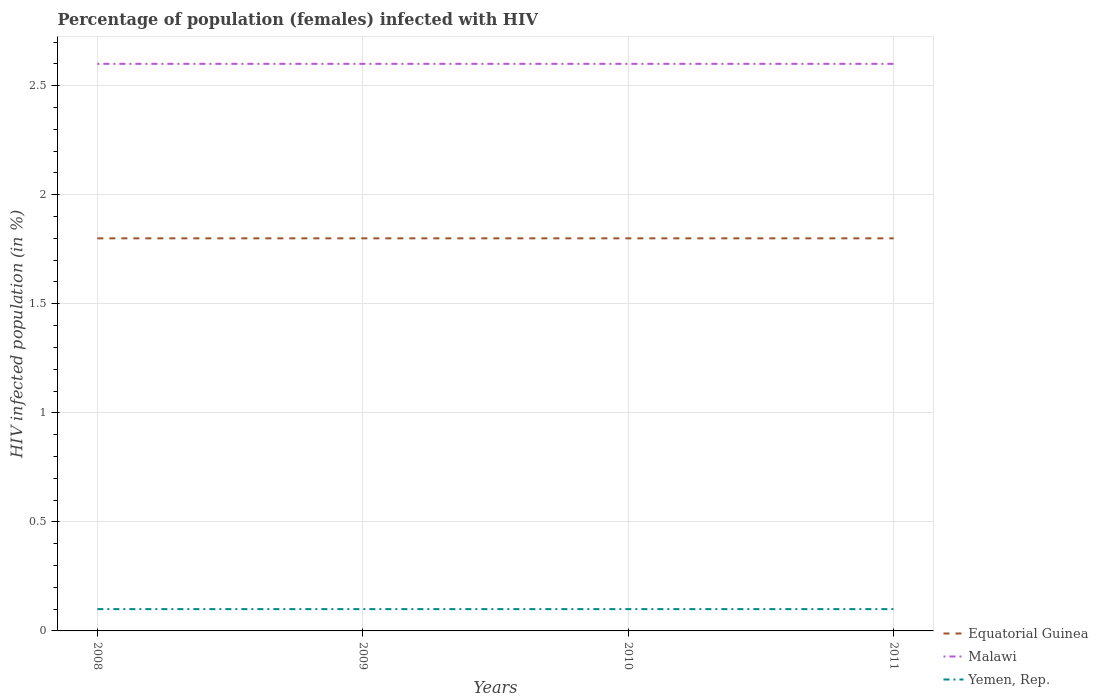Across all years, what is the maximum percentage of HIV infected female population in Equatorial Guinea?
Your answer should be compact. 1.8. In which year was the percentage of HIV infected female population in Yemen, Rep. maximum?
Provide a succinct answer. 2008. What is the difference between the highest and the second highest percentage of HIV infected female population in Malawi?
Ensure brevity in your answer.  0. Is the percentage of HIV infected female population in Equatorial Guinea strictly greater than the percentage of HIV infected female population in Yemen, Rep. over the years?
Give a very brief answer. No. How many lines are there?
Your answer should be very brief. 3. What is the difference between two consecutive major ticks on the Y-axis?
Offer a terse response. 0.5. Does the graph contain any zero values?
Give a very brief answer. No. Does the graph contain grids?
Ensure brevity in your answer.  Yes. How are the legend labels stacked?
Give a very brief answer. Vertical. What is the title of the graph?
Offer a terse response. Percentage of population (females) infected with HIV. Does "Cote d'Ivoire" appear as one of the legend labels in the graph?
Keep it short and to the point. No. What is the label or title of the Y-axis?
Ensure brevity in your answer.  HIV infected population (in %). What is the HIV infected population (in %) of Yemen, Rep. in 2008?
Provide a short and direct response. 0.1. What is the HIV infected population (in %) in Yemen, Rep. in 2009?
Make the answer very short. 0.1. What is the HIV infected population (in %) in Equatorial Guinea in 2010?
Make the answer very short. 1.8. What is the HIV infected population (in %) of Malawi in 2010?
Give a very brief answer. 2.6. Across all years, what is the maximum HIV infected population (in %) in Malawi?
Your answer should be compact. 2.6. Across all years, what is the minimum HIV infected population (in %) of Malawi?
Your answer should be very brief. 2.6. Across all years, what is the minimum HIV infected population (in %) of Yemen, Rep.?
Keep it short and to the point. 0.1. What is the total HIV infected population (in %) of Equatorial Guinea in the graph?
Your response must be concise. 7.2. What is the total HIV infected population (in %) of Malawi in the graph?
Your answer should be compact. 10.4. What is the difference between the HIV infected population (in %) of Equatorial Guinea in 2008 and that in 2009?
Give a very brief answer. 0. What is the difference between the HIV infected population (in %) in Malawi in 2008 and that in 2009?
Ensure brevity in your answer.  0. What is the difference between the HIV infected population (in %) in Yemen, Rep. in 2008 and that in 2009?
Give a very brief answer. 0. What is the difference between the HIV infected population (in %) in Malawi in 2008 and that in 2010?
Your response must be concise. 0. What is the difference between the HIV infected population (in %) in Yemen, Rep. in 2008 and that in 2010?
Offer a terse response. 0. What is the difference between the HIV infected population (in %) of Malawi in 2008 and that in 2011?
Offer a terse response. 0. What is the difference between the HIV infected population (in %) in Yemen, Rep. in 2008 and that in 2011?
Your answer should be compact. 0. What is the difference between the HIV infected population (in %) in Equatorial Guinea in 2009 and that in 2010?
Your response must be concise. 0. What is the difference between the HIV infected population (in %) in Malawi in 2009 and that in 2011?
Provide a short and direct response. 0. What is the difference between the HIV infected population (in %) in Yemen, Rep. in 2009 and that in 2011?
Give a very brief answer. 0. What is the difference between the HIV infected population (in %) of Equatorial Guinea in 2010 and that in 2011?
Provide a short and direct response. 0. What is the difference between the HIV infected population (in %) in Yemen, Rep. in 2010 and that in 2011?
Ensure brevity in your answer.  0. What is the difference between the HIV infected population (in %) of Equatorial Guinea in 2008 and the HIV infected population (in %) of Malawi in 2010?
Give a very brief answer. -0.8. What is the difference between the HIV infected population (in %) of Malawi in 2008 and the HIV infected population (in %) of Yemen, Rep. in 2010?
Provide a short and direct response. 2.5. What is the difference between the HIV infected population (in %) of Equatorial Guinea in 2008 and the HIV infected population (in %) of Yemen, Rep. in 2011?
Ensure brevity in your answer.  1.7. What is the difference between the HIV infected population (in %) of Malawi in 2008 and the HIV infected population (in %) of Yemen, Rep. in 2011?
Keep it short and to the point. 2.5. What is the difference between the HIV infected population (in %) of Equatorial Guinea in 2009 and the HIV infected population (in %) of Malawi in 2010?
Your answer should be compact. -0.8. What is the difference between the HIV infected population (in %) in Malawi in 2009 and the HIV infected population (in %) in Yemen, Rep. in 2010?
Keep it short and to the point. 2.5. What is the average HIV infected population (in %) in Malawi per year?
Your answer should be compact. 2.6. What is the average HIV infected population (in %) of Yemen, Rep. per year?
Your answer should be compact. 0.1. In the year 2008, what is the difference between the HIV infected population (in %) in Equatorial Guinea and HIV infected population (in %) in Malawi?
Your answer should be very brief. -0.8. In the year 2008, what is the difference between the HIV infected population (in %) of Equatorial Guinea and HIV infected population (in %) of Yemen, Rep.?
Give a very brief answer. 1.7. In the year 2009, what is the difference between the HIV infected population (in %) of Equatorial Guinea and HIV infected population (in %) of Malawi?
Offer a terse response. -0.8. In the year 2009, what is the difference between the HIV infected population (in %) of Equatorial Guinea and HIV infected population (in %) of Yemen, Rep.?
Your answer should be compact. 1.7. In the year 2010, what is the difference between the HIV infected population (in %) of Equatorial Guinea and HIV infected population (in %) of Malawi?
Provide a succinct answer. -0.8. In the year 2010, what is the difference between the HIV infected population (in %) in Equatorial Guinea and HIV infected population (in %) in Yemen, Rep.?
Keep it short and to the point. 1.7. In the year 2011, what is the difference between the HIV infected population (in %) in Equatorial Guinea and HIV infected population (in %) in Yemen, Rep.?
Your response must be concise. 1.7. In the year 2011, what is the difference between the HIV infected population (in %) in Malawi and HIV infected population (in %) in Yemen, Rep.?
Offer a terse response. 2.5. What is the ratio of the HIV infected population (in %) of Equatorial Guinea in 2008 to that in 2009?
Make the answer very short. 1. What is the ratio of the HIV infected population (in %) of Malawi in 2008 to that in 2009?
Give a very brief answer. 1. What is the ratio of the HIV infected population (in %) of Equatorial Guinea in 2008 to that in 2010?
Give a very brief answer. 1. What is the ratio of the HIV infected population (in %) of Equatorial Guinea in 2008 to that in 2011?
Your response must be concise. 1. What is the ratio of the HIV infected population (in %) of Malawi in 2009 to that in 2010?
Make the answer very short. 1. What is the ratio of the HIV infected population (in %) of Malawi in 2009 to that in 2011?
Your response must be concise. 1. What is the ratio of the HIV infected population (in %) in Yemen, Rep. in 2010 to that in 2011?
Your answer should be compact. 1. What is the difference between the highest and the second highest HIV infected population (in %) in Malawi?
Provide a short and direct response. 0. What is the difference between the highest and the lowest HIV infected population (in %) in Malawi?
Make the answer very short. 0. What is the difference between the highest and the lowest HIV infected population (in %) of Yemen, Rep.?
Provide a short and direct response. 0. 